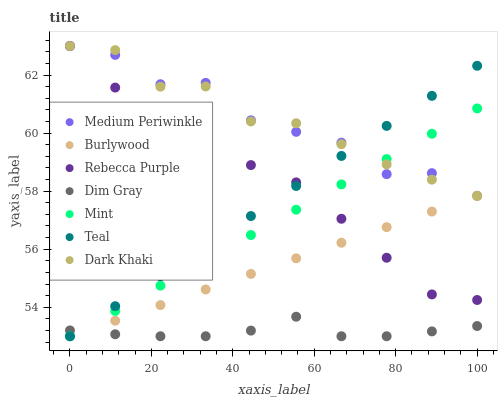Does Dim Gray have the minimum area under the curve?
Answer yes or no. Yes. Does Dark Khaki have the maximum area under the curve?
Answer yes or no. Yes. Does Burlywood have the minimum area under the curve?
Answer yes or no. No. Does Burlywood have the maximum area under the curve?
Answer yes or no. No. Is Burlywood the smoothest?
Answer yes or no. Yes. Is Medium Periwinkle the roughest?
Answer yes or no. Yes. Is Medium Periwinkle the smoothest?
Answer yes or no. No. Is Burlywood the roughest?
Answer yes or no. No. Does Dim Gray have the lowest value?
Answer yes or no. Yes. Does Medium Periwinkle have the lowest value?
Answer yes or no. No. Does Rebecca Purple have the highest value?
Answer yes or no. Yes. Does Burlywood have the highest value?
Answer yes or no. No. Is Dim Gray less than Medium Periwinkle?
Answer yes or no. Yes. Is Dark Khaki greater than Dim Gray?
Answer yes or no. Yes. Does Dark Khaki intersect Medium Periwinkle?
Answer yes or no. Yes. Is Dark Khaki less than Medium Periwinkle?
Answer yes or no. No. Is Dark Khaki greater than Medium Periwinkle?
Answer yes or no. No. Does Dim Gray intersect Medium Periwinkle?
Answer yes or no. No. 